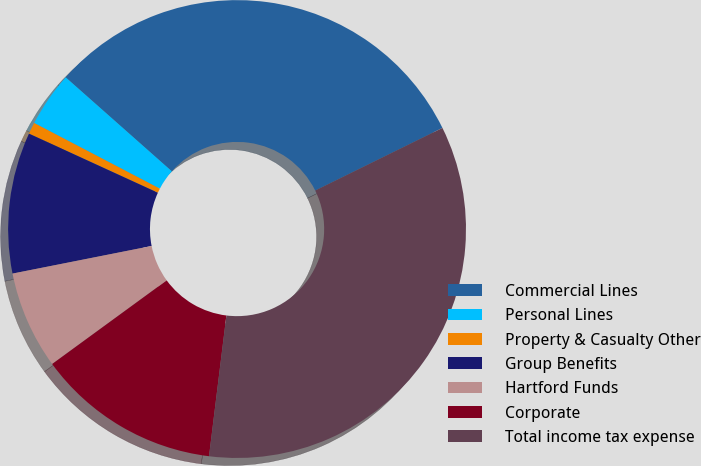<chart> <loc_0><loc_0><loc_500><loc_500><pie_chart><fcel>Commercial Lines<fcel>Personal Lines<fcel>Property & Casualty Other<fcel>Group Benefits<fcel>Hartford Funds<fcel>Corporate<fcel>Total income tax expense<nl><fcel>31.19%<fcel>3.87%<fcel>0.82%<fcel>9.96%<fcel>6.92%<fcel>13.01%<fcel>34.24%<nl></chart> 